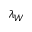Convert formula to latex. <formula><loc_0><loc_0><loc_500><loc_500>\lambda _ { W }</formula> 